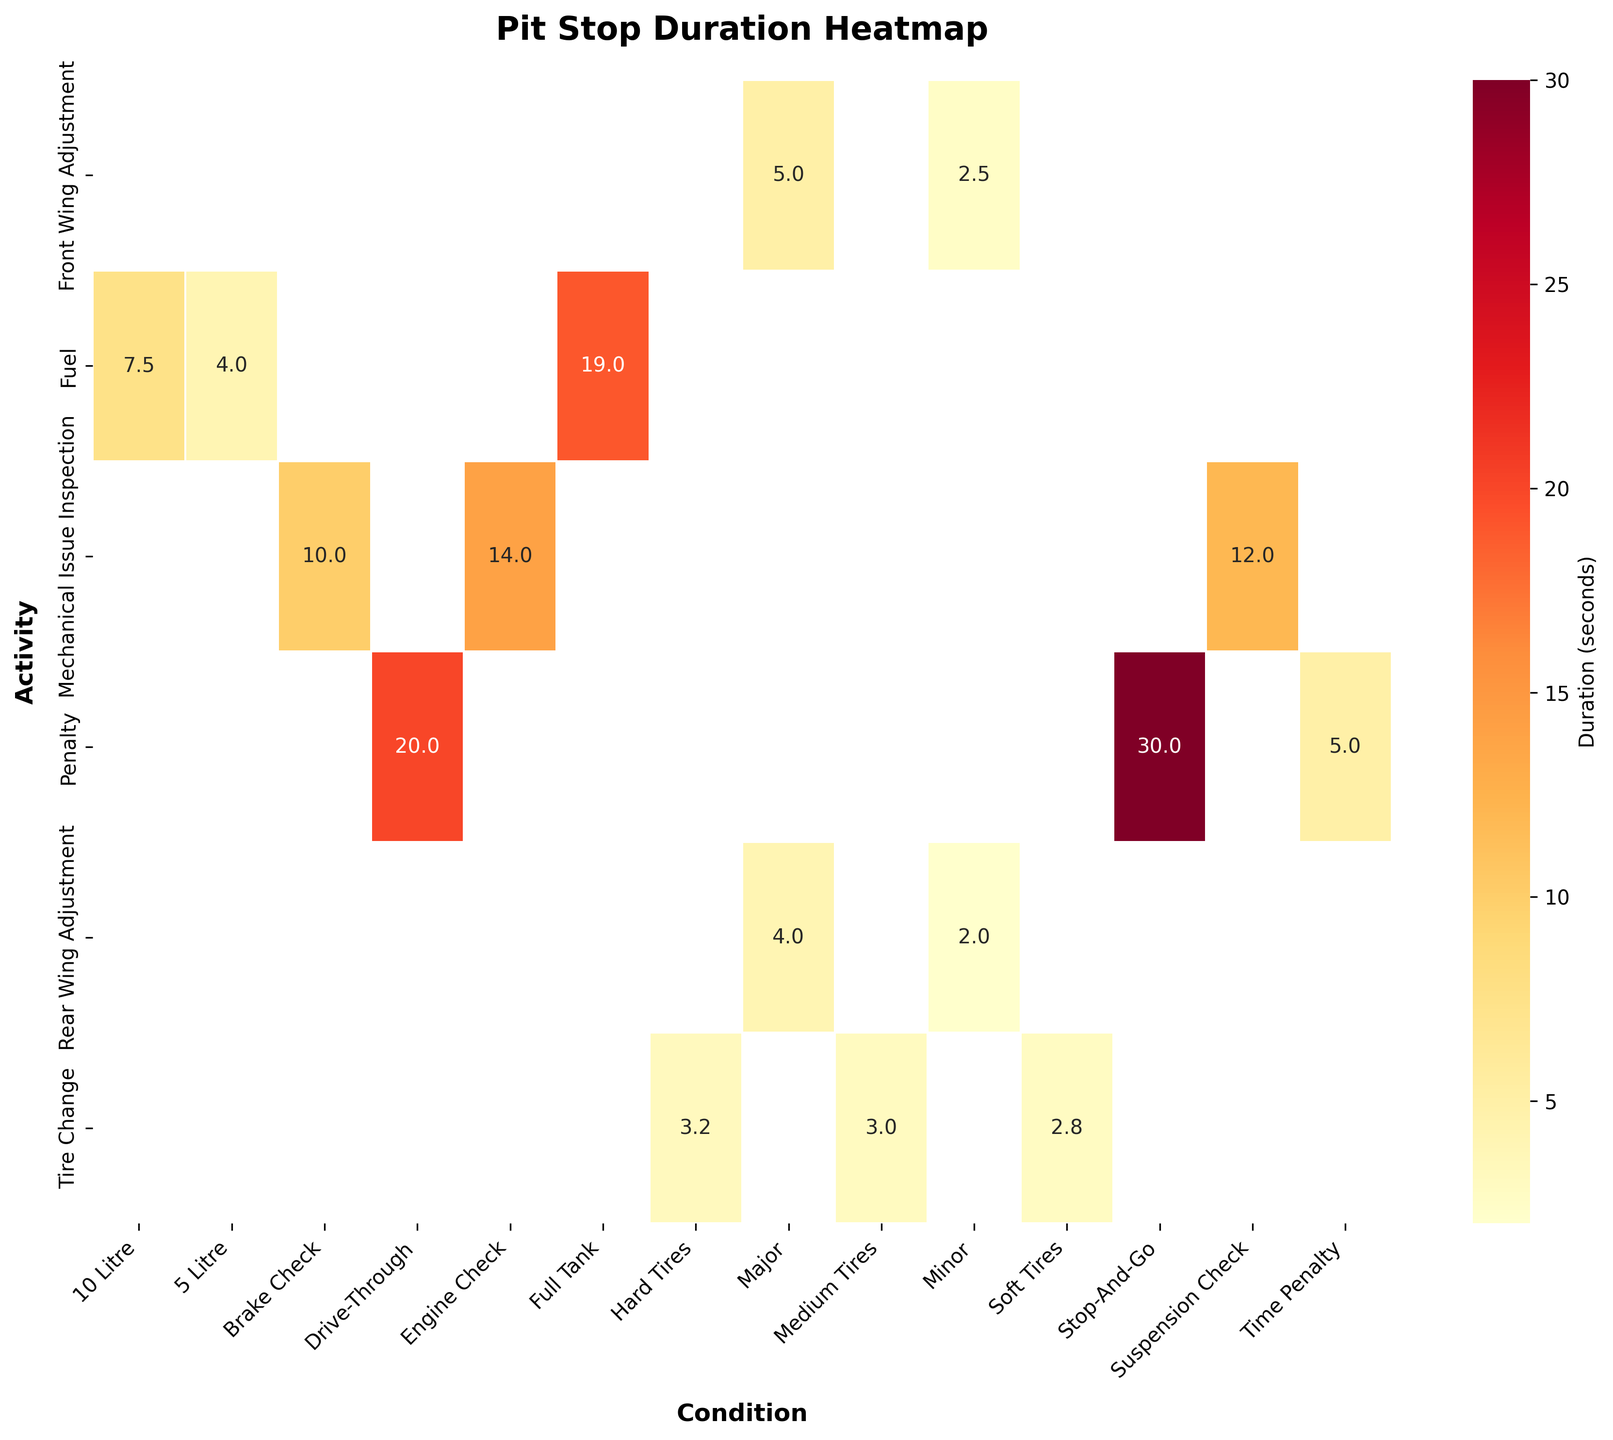What is the duration for a full tank of Fuel? Look at the intersection between the "Fuel" row and the "Full Tank" column in the heatmap. The duration is 19.0 seconds.
Answer: 19.0 seconds Which activity has the longest duration and what is it? Identify the highest value in the heatmap. The longest duration is 30.0 seconds and it is associated with the "Penalty" activity for the "Stop-And-Go" condition.
Answer: Penalty: Stop-And-Go, 30.0 seconds How long does a Minor Rear Wing Adjustment take? Find the "Rear Wing Adjustment" row and look for the "Minor" column. The duration is 2.0 seconds.
Answer: 2.0 seconds Which condition for Tire Change has the shortest duration and what is it? Examine the "Tire Change" row and identify the smallest value among the conditions "Soft Tires," "Medium Tires," and "Hard Tires." The shortest duration is 2.8 seconds for "Soft Tires."
Answer: Soft Tires, 2.8 seconds What is the average duration for activities under the condition "Major"? Calculate the mean value of the durations given for "Major" conditions, which are 5.0 (Front Wing Adjustment) and 4.0 (Rear Wing Adjustment). (5.0 + 4.0) / 2 = 4.5 seconds.
Answer: 4.5 seconds Compare the durations for Brake Check and Engine Check under Mechanical Issue Inspection. Which one is longer and by how much? Determine the durations for Brake Check (10.0 seconds) and Engine Check (14.0 seconds). Engine Check is longer by (14.0 - 10.0) = 4.0 seconds.
Answer: Engine Check, 4.0 seconds longer What is the total duration for Penalty activities? Sum the durations of all Penalty activities: 20.0 (Drive-Through) + 30.0 (Stop-And-Go) + 5.0 (Time Penalty) = 55.0 seconds.
Answer: 55.0 seconds Which activity and condition combination has the least duration and what is it? Identify the smallest value in the heatmap, which is 2.0 seconds for "Rear Wing Adjustment" with the "Minor" condition.
Answer: Rear Wing Adjustment: Minor, 2.0 seconds How does the duration for Front Wing Adjustment under Minor condition compare to a Minor Rear Wing Adjustment? Find the durations for Front Wing Adjustment: Minor (2.5 seconds) and Rear Wing Adjustment: Minor (2.0 seconds). Rear Wing Adjustment: Minor is shorter by (2.5 - 2.0) = 0.5 seconds.
Answer: Front Wing Adjustment: Minor is 0.5 seconds longer 